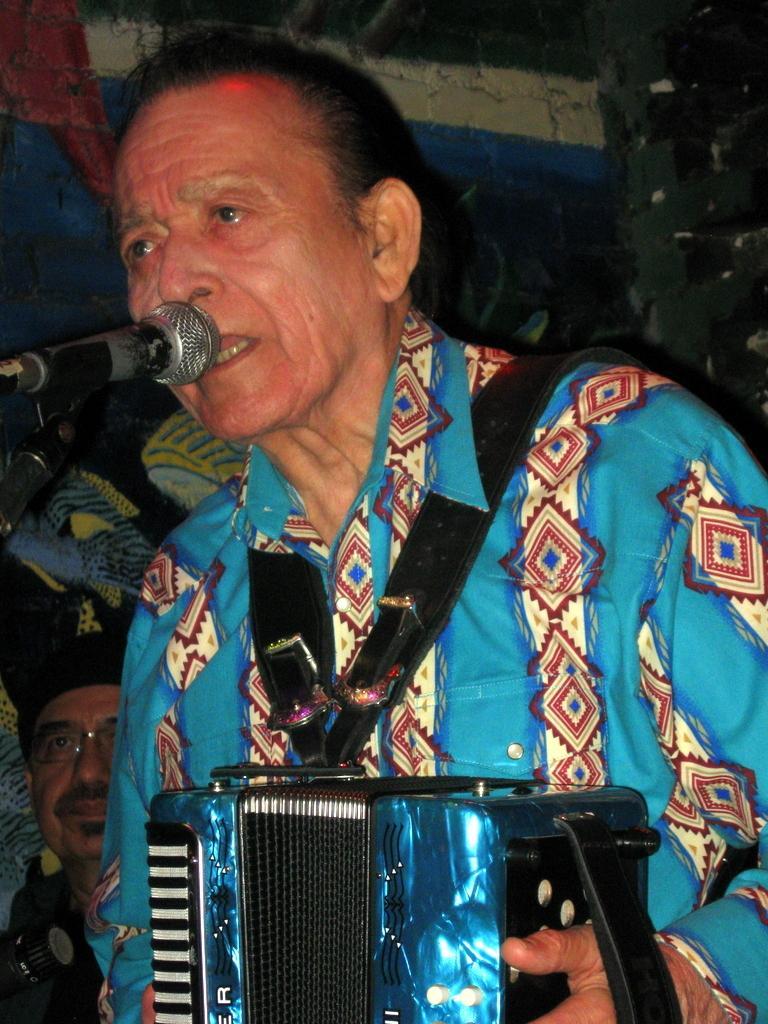Could you give a brief overview of what you see in this image? In this picture there is a person in blue dress playing a musical instrument and singing into microphone. On the left there is a person. In the background it is wall painted with different colors. 